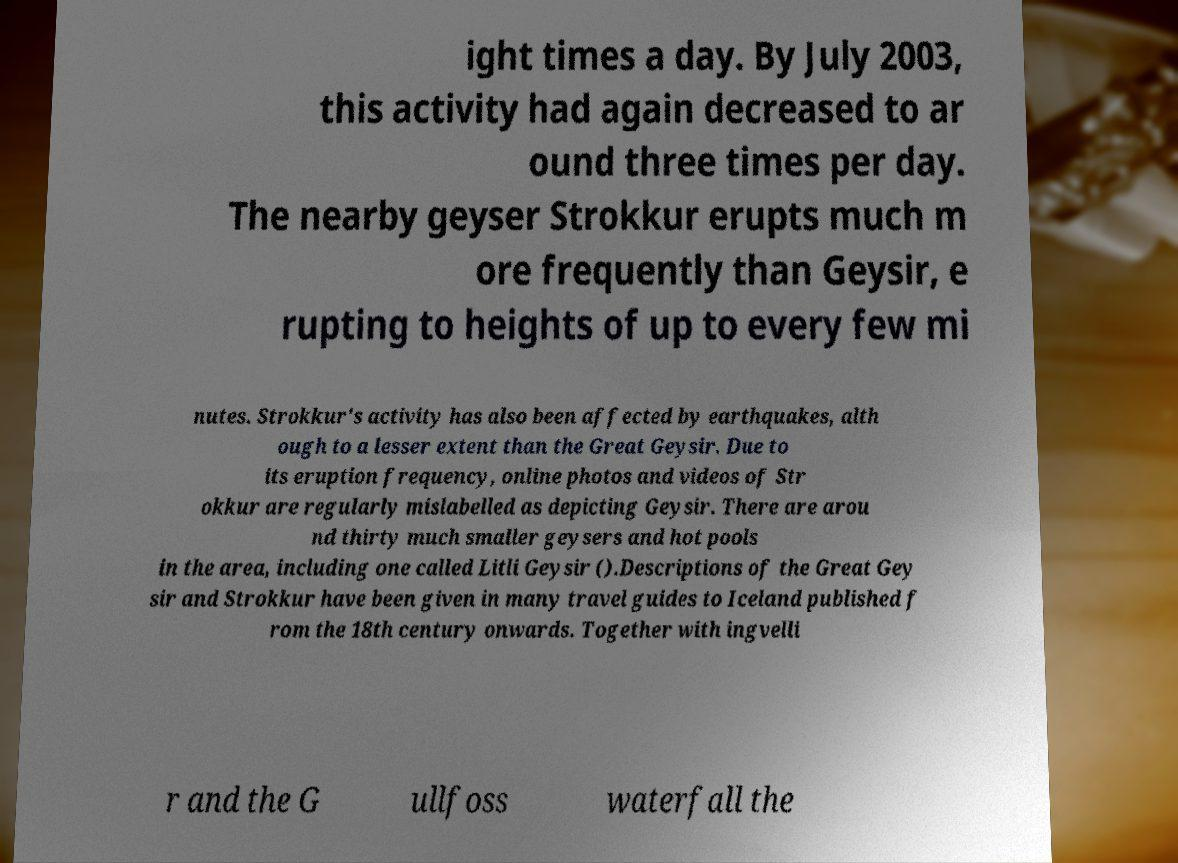Please identify and transcribe the text found in this image. ight times a day. By July 2003, this activity had again decreased to ar ound three times per day. The nearby geyser Strokkur erupts much m ore frequently than Geysir, e rupting to heights of up to every few mi nutes. Strokkur's activity has also been affected by earthquakes, alth ough to a lesser extent than the Great Geysir. Due to its eruption frequency, online photos and videos of Str okkur are regularly mislabelled as depicting Geysir. There are arou nd thirty much smaller geysers and hot pools in the area, including one called Litli Geysir ().Descriptions of the Great Gey sir and Strokkur have been given in many travel guides to Iceland published f rom the 18th century onwards. Together with ingvelli r and the G ullfoss waterfall the 